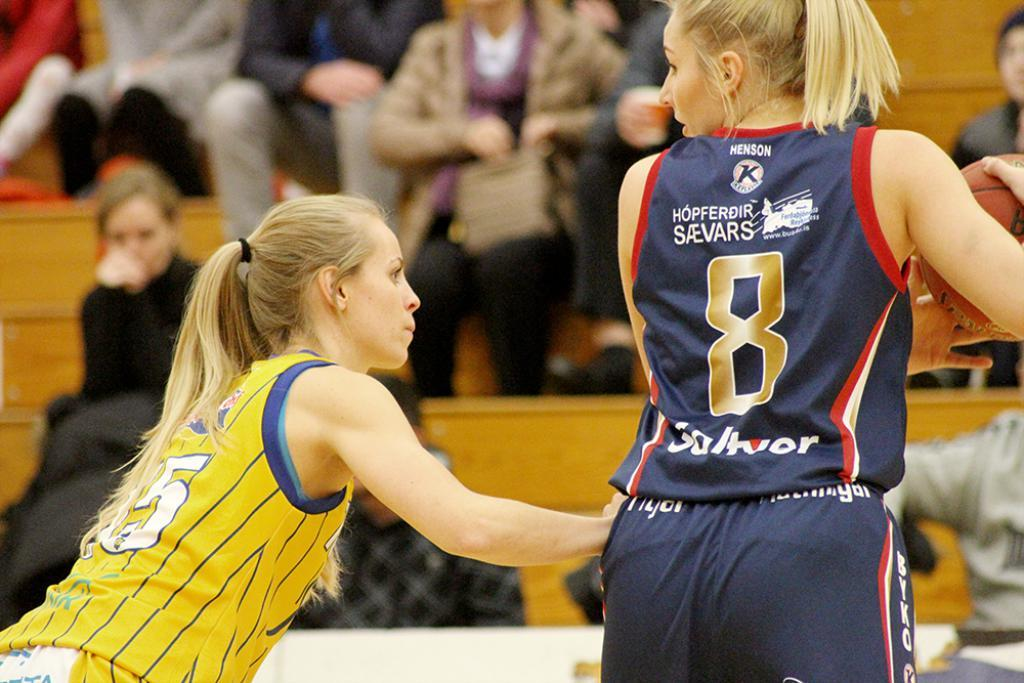<image>
Describe the image concisely. Women competing in a basketball match holding the ball and sponsored by Henson. 